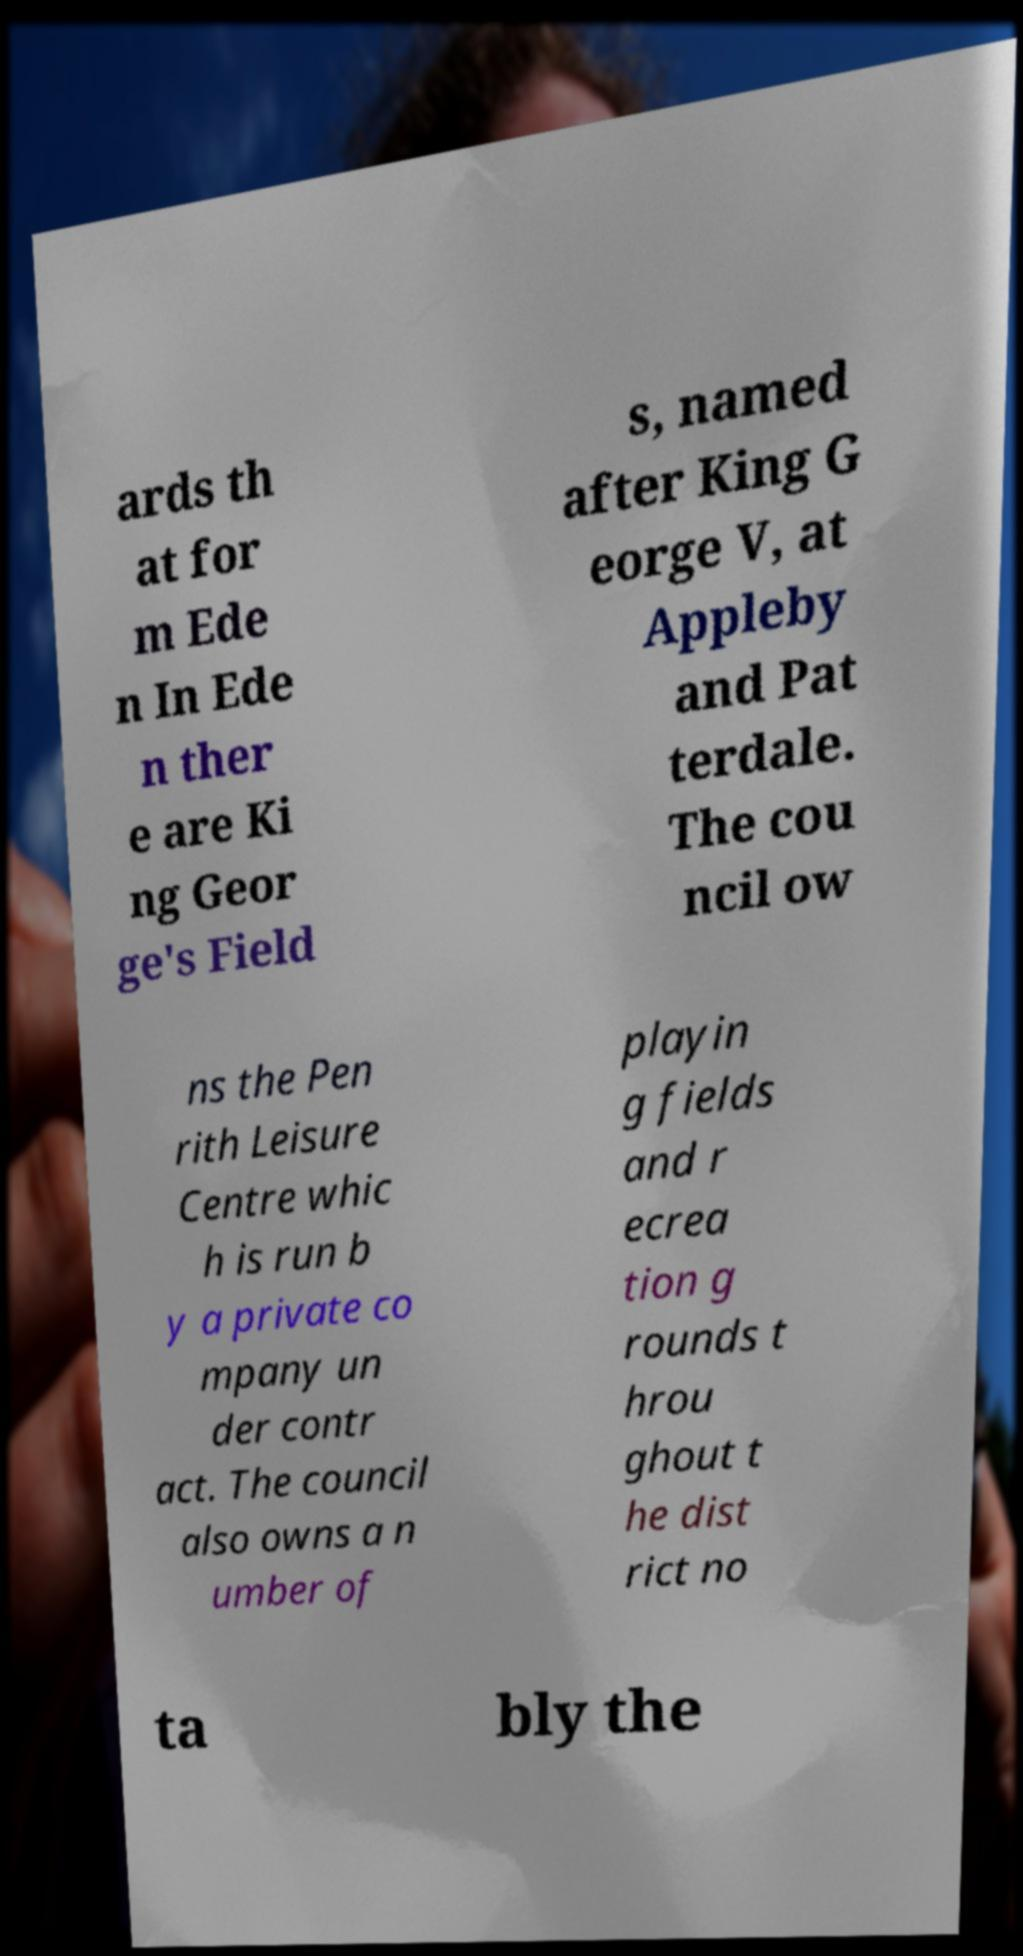What messages or text are displayed in this image? I need them in a readable, typed format. ards th at for m Ede n In Ede n ther e are Ki ng Geor ge's Field s, named after King G eorge V, at Appleby and Pat terdale. The cou ncil ow ns the Pen rith Leisure Centre whic h is run b y a private co mpany un der contr act. The council also owns a n umber of playin g fields and r ecrea tion g rounds t hrou ghout t he dist rict no ta bly the 